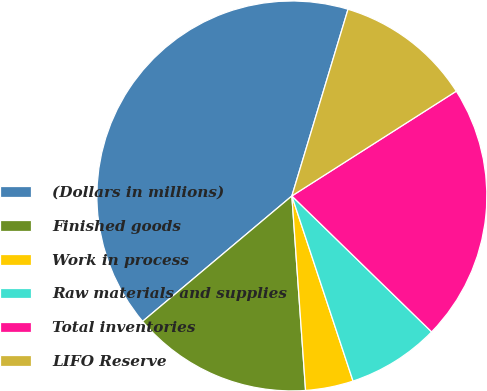Convert chart. <chart><loc_0><loc_0><loc_500><loc_500><pie_chart><fcel>(Dollars in millions)<fcel>Finished goods<fcel>Work in process<fcel>Raw materials and supplies<fcel>Total inventories<fcel>LIFO Reserve<nl><fcel>40.77%<fcel>15.0%<fcel>3.96%<fcel>7.64%<fcel>21.31%<fcel>11.32%<nl></chart> 